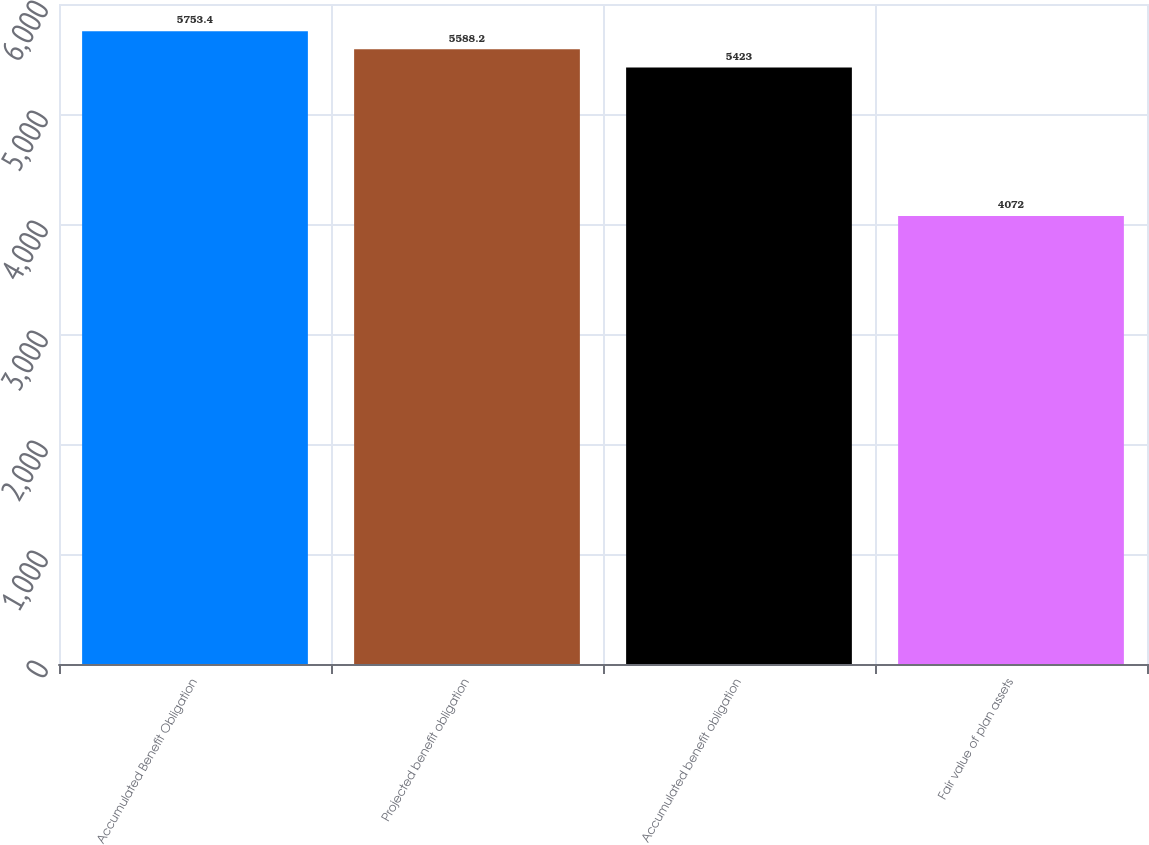Convert chart to OTSL. <chart><loc_0><loc_0><loc_500><loc_500><bar_chart><fcel>Accumulated Benefit Obligation<fcel>Projected benefit obligation<fcel>Accumulated benefit obligation<fcel>Fair value of plan assets<nl><fcel>5753.4<fcel>5588.2<fcel>5423<fcel>4072<nl></chart> 